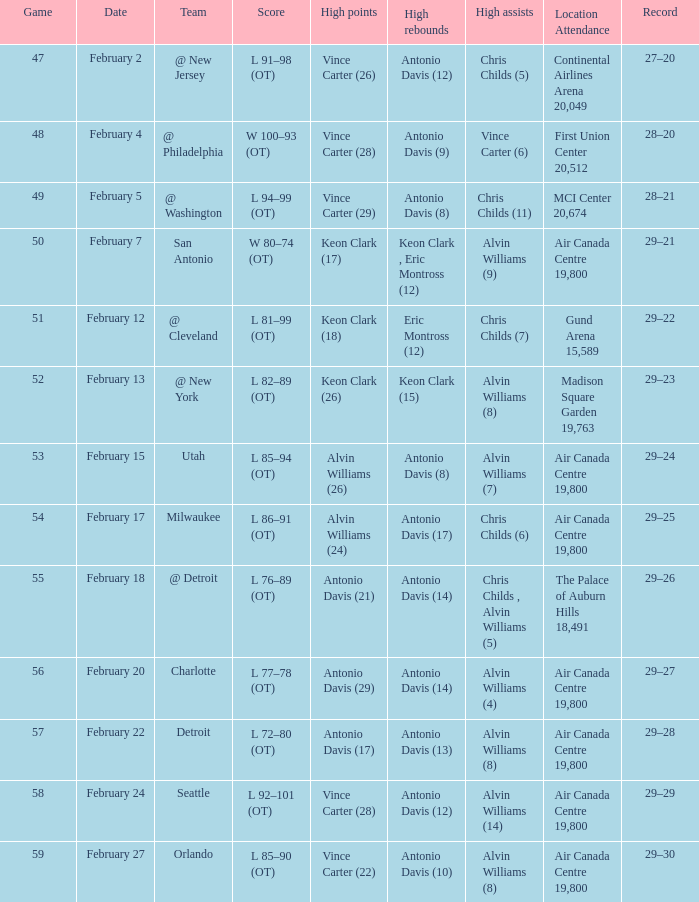What is the record for the highest rebounds by antonio davis, which is 9? 28–20. Can you parse all the data within this table? {'header': ['Game', 'Date', 'Team', 'Score', 'High points', 'High rebounds', 'High assists', 'Location Attendance', 'Record'], 'rows': [['47', 'February 2', '@ New Jersey', 'L 91–98 (OT)', 'Vince Carter (26)', 'Antonio Davis (12)', 'Chris Childs (5)', 'Continental Airlines Arena 20,049', '27–20'], ['48', 'February 4', '@ Philadelphia', 'W 100–93 (OT)', 'Vince Carter (28)', 'Antonio Davis (9)', 'Vince Carter (6)', 'First Union Center 20,512', '28–20'], ['49', 'February 5', '@ Washington', 'L 94–99 (OT)', 'Vince Carter (29)', 'Antonio Davis (8)', 'Chris Childs (11)', 'MCI Center 20,674', '28–21'], ['50', 'February 7', 'San Antonio', 'W 80–74 (OT)', 'Keon Clark (17)', 'Keon Clark , Eric Montross (12)', 'Alvin Williams (9)', 'Air Canada Centre 19,800', '29–21'], ['51', 'February 12', '@ Cleveland', 'L 81–99 (OT)', 'Keon Clark (18)', 'Eric Montross (12)', 'Chris Childs (7)', 'Gund Arena 15,589', '29–22'], ['52', 'February 13', '@ New York', 'L 82–89 (OT)', 'Keon Clark (26)', 'Keon Clark (15)', 'Alvin Williams (8)', 'Madison Square Garden 19,763', '29–23'], ['53', 'February 15', 'Utah', 'L 85–94 (OT)', 'Alvin Williams (26)', 'Antonio Davis (8)', 'Alvin Williams (7)', 'Air Canada Centre 19,800', '29–24'], ['54', 'February 17', 'Milwaukee', 'L 86–91 (OT)', 'Alvin Williams (24)', 'Antonio Davis (17)', 'Chris Childs (6)', 'Air Canada Centre 19,800', '29–25'], ['55', 'February 18', '@ Detroit', 'L 76–89 (OT)', 'Antonio Davis (21)', 'Antonio Davis (14)', 'Chris Childs , Alvin Williams (5)', 'The Palace of Auburn Hills 18,491', '29–26'], ['56', 'February 20', 'Charlotte', 'L 77–78 (OT)', 'Antonio Davis (29)', 'Antonio Davis (14)', 'Alvin Williams (4)', 'Air Canada Centre 19,800', '29–27'], ['57', 'February 22', 'Detroit', 'L 72–80 (OT)', 'Antonio Davis (17)', 'Antonio Davis (13)', 'Alvin Williams (8)', 'Air Canada Centre 19,800', '29–28'], ['58', 'February 24', 'Seattle', 'L 92–101 (OT)', 'Vince Carter (28)', 'Antonio Davis (12)', 'Alvin Williams (14)', 'Air Canada Centre 19,800', '29–29'], ['59', 'February 27', 'Orlando', 'L 85–90 (OT)', 'Vince Carter (22)', 'Antonio Davis (10)', 'Alvin Williams (8)', 'Air Canada Centre 19,800', '29–30']]} 